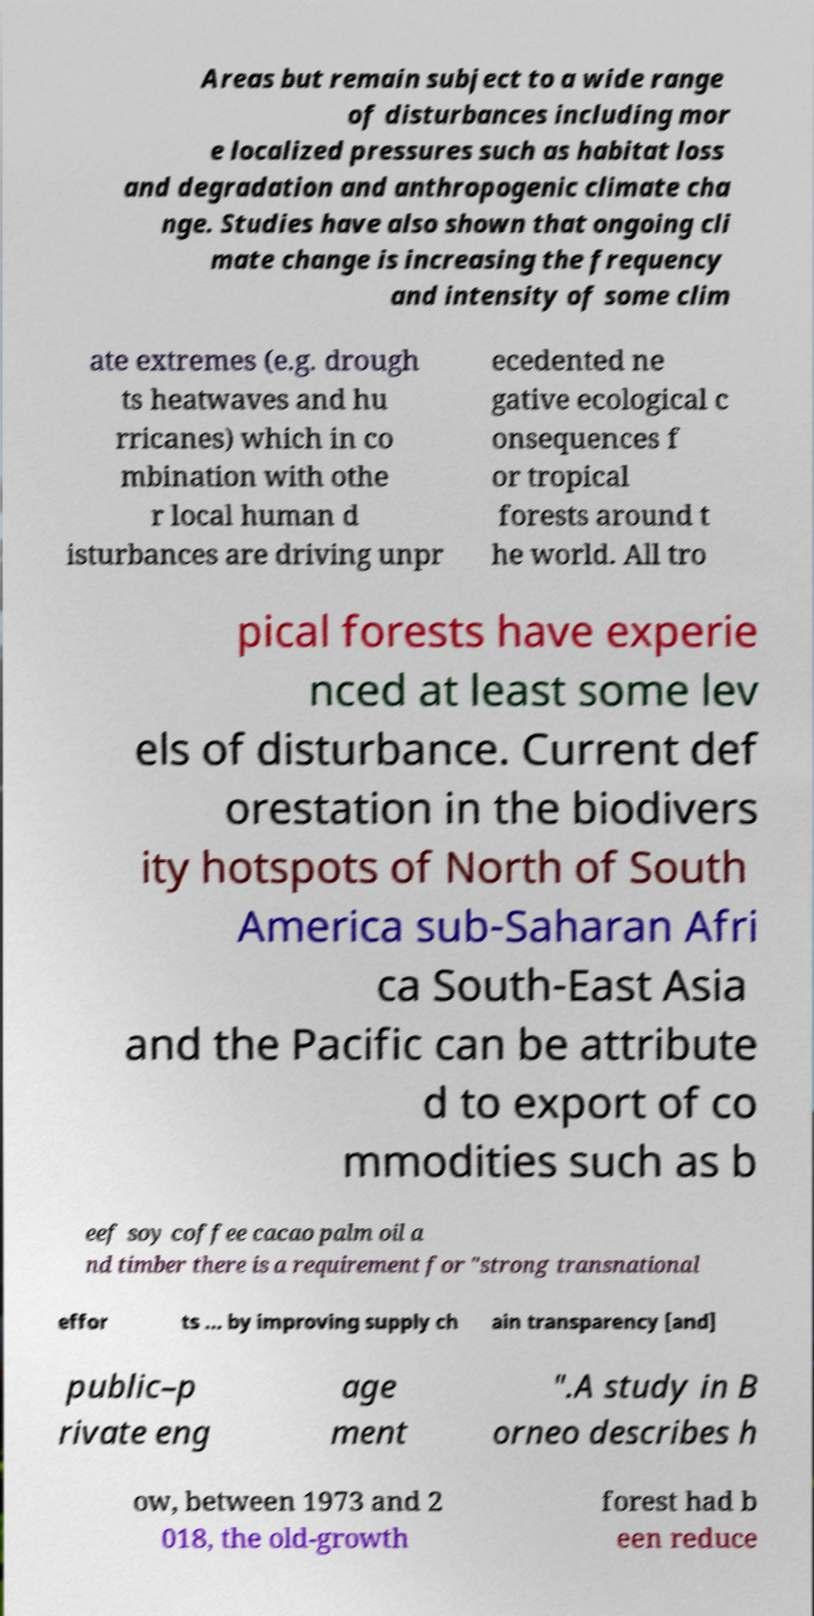Could you assist in decoding the text presented in this image and type it out clearly? Areas but remain subject to a wide range of disturbances including mor e localized pressures such as habitat loss and degradation and anthropogenic climate cha nge. Studies have also shown that ongoing cli mate change is increasing the frequency and intensity of some clim ate extremes (e.g. drough ts heatwaves and hu rricanes) which in co mbination with othe r local human d isturbances are driving unpr ecedented ne gative ecological c onsequences f or tropical forests around t he world. All tro pical forests have experie nced at least some lev els of disturbance. Current def orestation in the biodivers ity hotspots of North of South America sub-Saharan Afri ca South-East Asia and the Pacific can be attribute d to export of co mmodities such as b eef soy coffee cacao palm oil a nd timber there is a requirement for "strong transnational effor ts ... by improving supply ch ain transparency [and] public–p rivate eng age ment ".A study in B orneo describes h ow, between 1973 and 2 018, the old-growth forest had b een reduce 